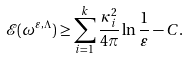Convert formula to latex. <formula><loc_0><loc_0><loc_500><loc_500>\mathcal { E } ( \omega ^ { \varepsilon , \Lambda } ) \geq \sum _ { i = 1 } ^ { k } \frac { \kappa _ { i } ^ { 2 } } { 4 \pi } \ln { \frac { 1 } { \varepsilon } } - C .</formula> 